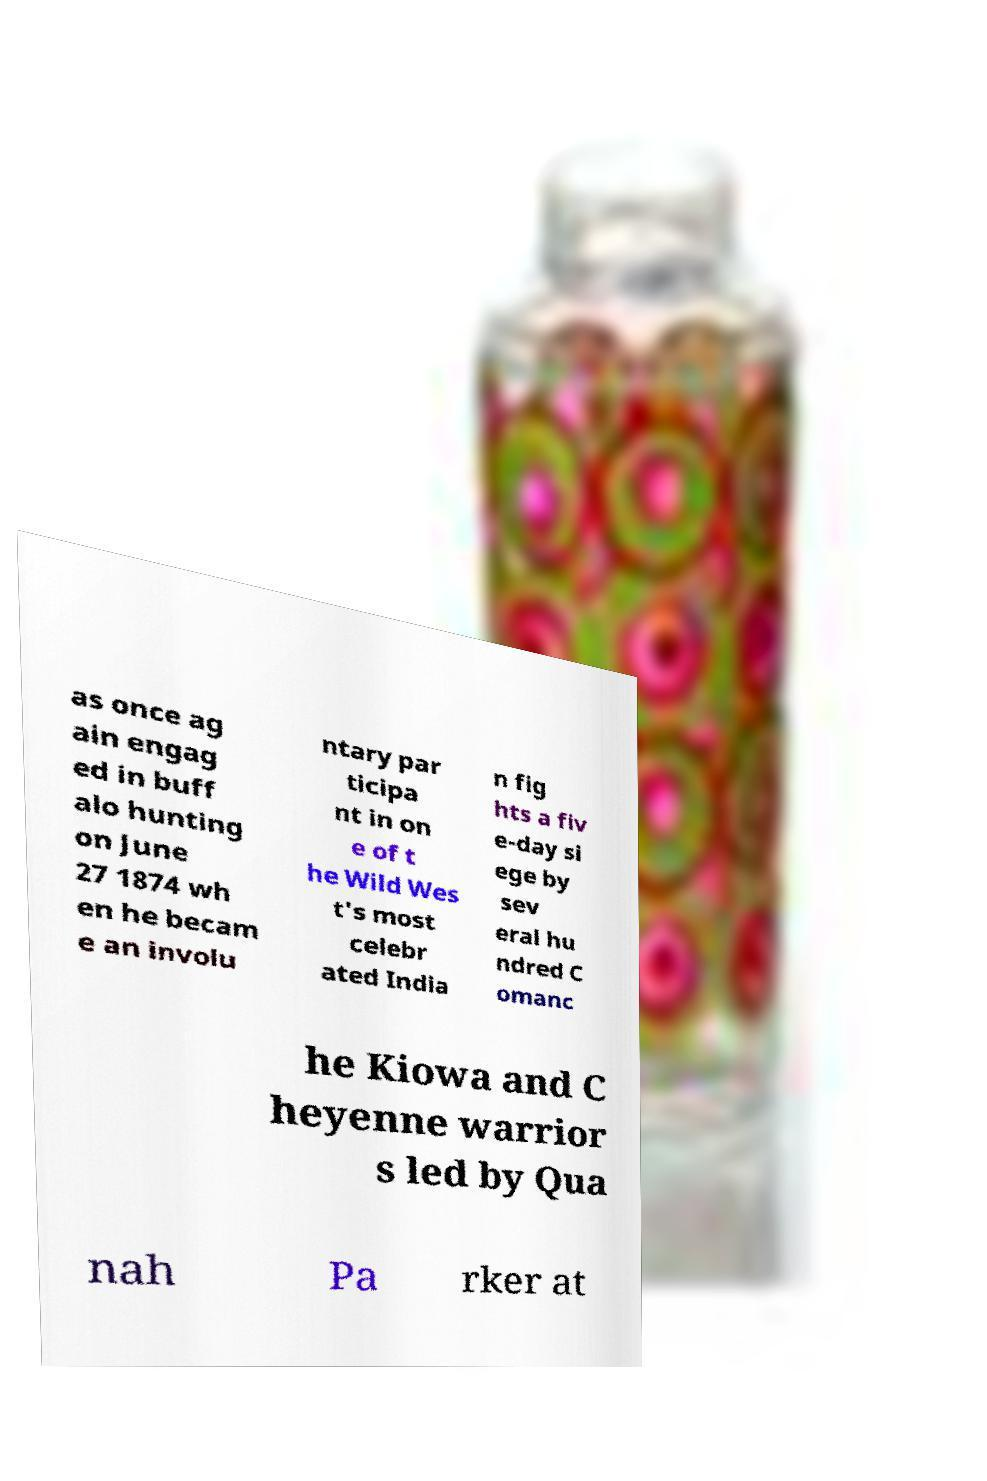Can you accurately transcribe the text from the provided image for me? as once ag ain engag ed in buff alo hunting on June 27 1874 wh en he becam e an involu ntary par ticipa nt in on e of t he Wild Wes t's most celebr ated India n fig hts a fiv e-day si ege by sev eral hu ndred C omanc he Kiowa and C heyenne warrior s led by Qua nah Pa rker at 